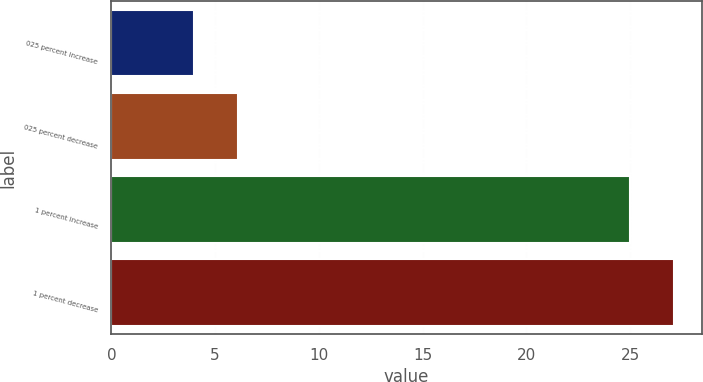Convert chart to OTSL. <chart><loc_0><loc_0><loc_500><loc_500><bar_chart><fcel>025 percent increase<fcel>025 percent decrease<fcel>1 percent increase<fcel>1 percent decrease<nl><fcel>4<fcel>6.1<fcel>25<fcel>27.1<nl></chart> 